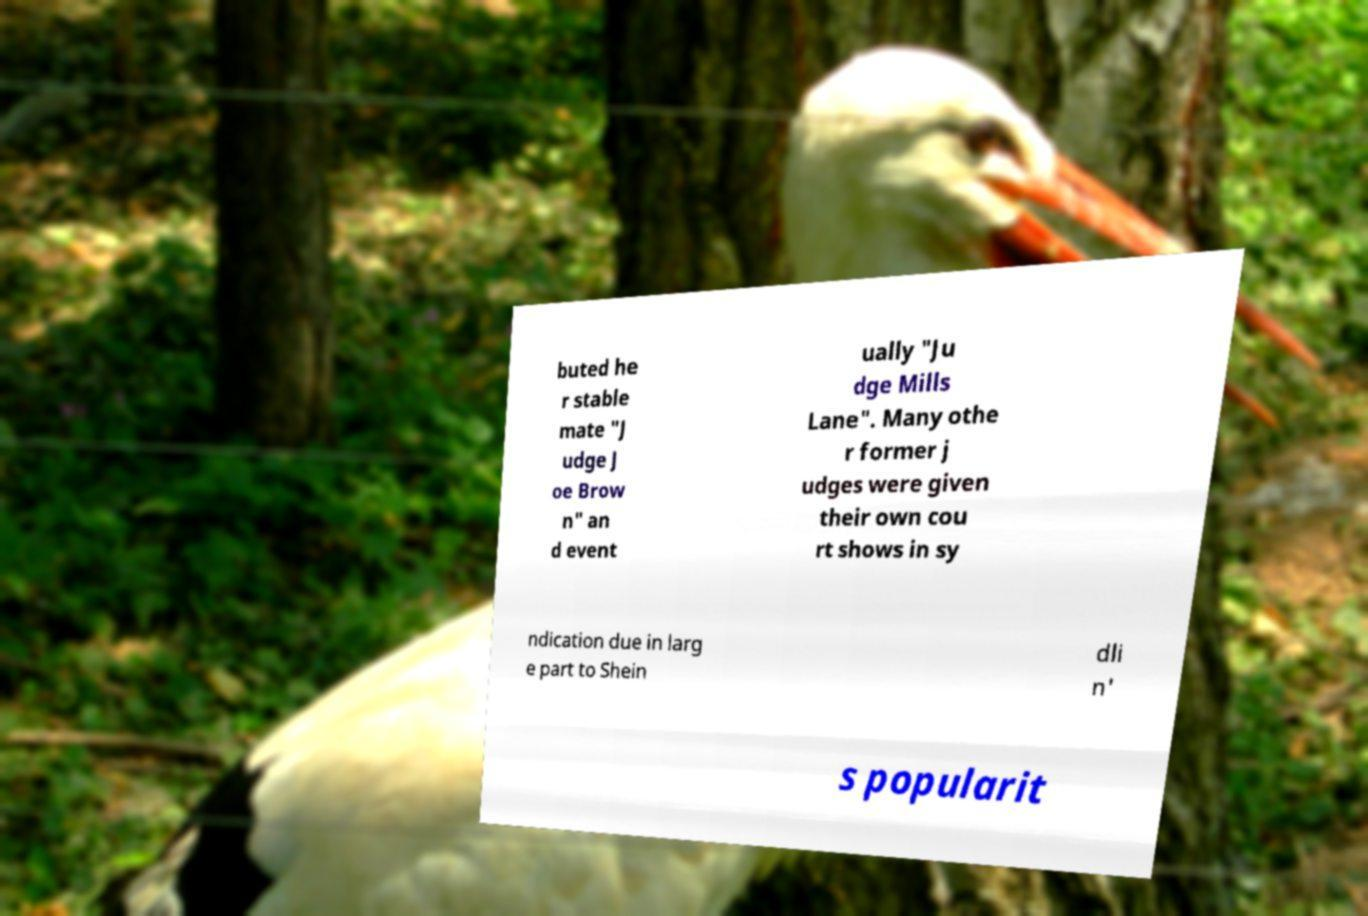Please read and relay the text visible in this image. What does it say? buted he r stable mate "J udge J oe Brow n" an d event ually "Ju dge Mills Lane". Many othe r former j udges were given their own cou rt shows in sy ndication due in larg e part to Shein dli n' s popularit 